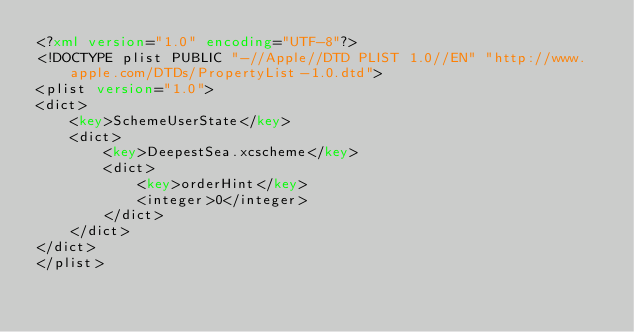Convert code to text. <code><loc_0><loc_0><loc_500><loc_500><_XML_><?xml version="1.0" encoding="UTF-8"?>
<!DOCTYPE plist PUBLIC "-//Apple//DTD PLIST 1.0//EN" "http://www.apple.com/DTDs/PropertyList-1.0.dtd">
<plist version="1.0">
<dict>
	<key>SchemeUserState</key>
	<dict>
		<key>DeepestSea.xcscheme</key>
		<dict>
			<key>orderHint</key>
			<integer>0</integer>
		</dict>
	</dict>
</dict>
</plist>
</code> 